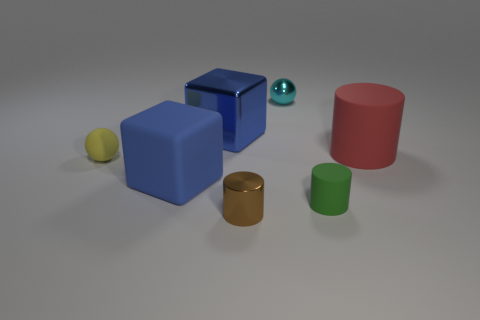Subtract all large red cylinders. How many cylinders are left? 2 Add 1 metal blocks. How many objects exist? 8 Subtract all brown cylinders. How many cylinders are left? 2 Subtract all cubes. How many objects are left? 5 Subtract 1 spheres. How many spheres are left? 1 Subtract all yellow spheres. Subtract all yellow cylinders. How many spheres are left? 1 Subtract all purple cylinders. How many yellow spheres are left? 1 Subtract all big red rubber objects. Subtract all metallic spheres. How many objects are left? 5 Add 3 big red matte cylinders. How many big red matte cylinders are left? 4 Add 1 large brown objects. How many large brown objects exist? 1 